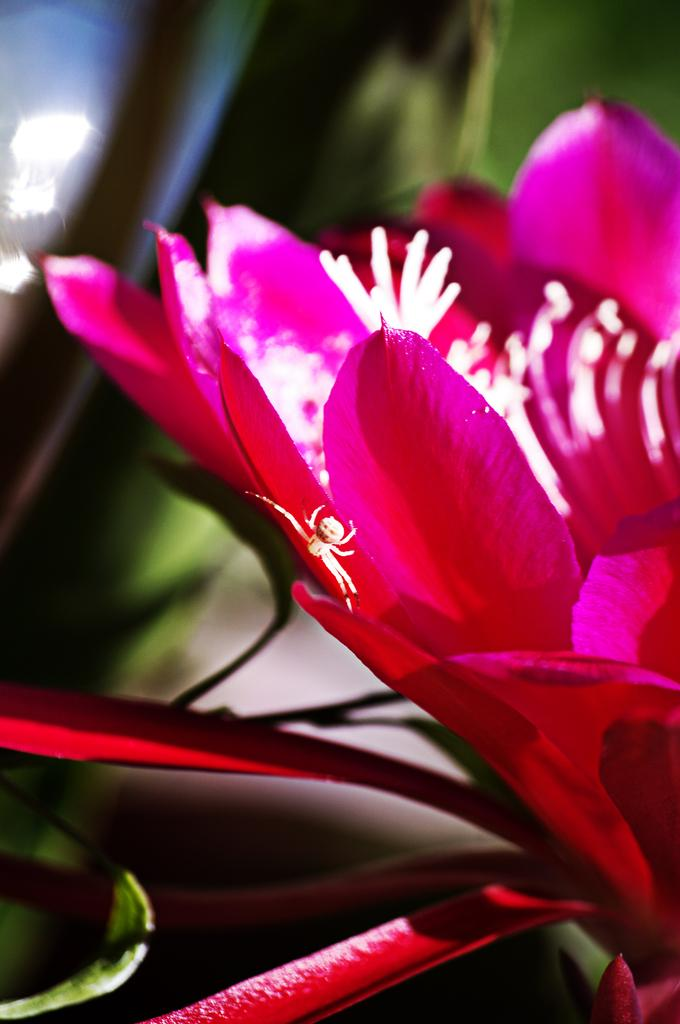What is present in the image? There is an insect in the image. Where is the insect located? The insect is on a flower. Can you describe the background of the image? The background of the image is blurry. What type of owl can be seen learning from its pet in the image? There is no owl or pet present in the image; it features an insect on a flower with a blurry background. 